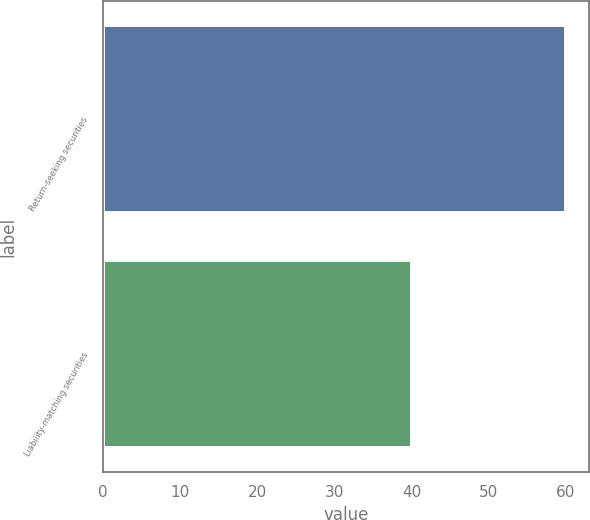Convert chart. <chart><loc_0><loc_0><loc_500><loc_500><bar_chart><fcel>Return-seeking securities<fcel>Liability-matching securities<nl><fcel>60<fcel>40<nl></chart> 